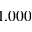<formula> <loc_0><loc_0><loc_500><loc_500>1 . 0 0 0</formula> 